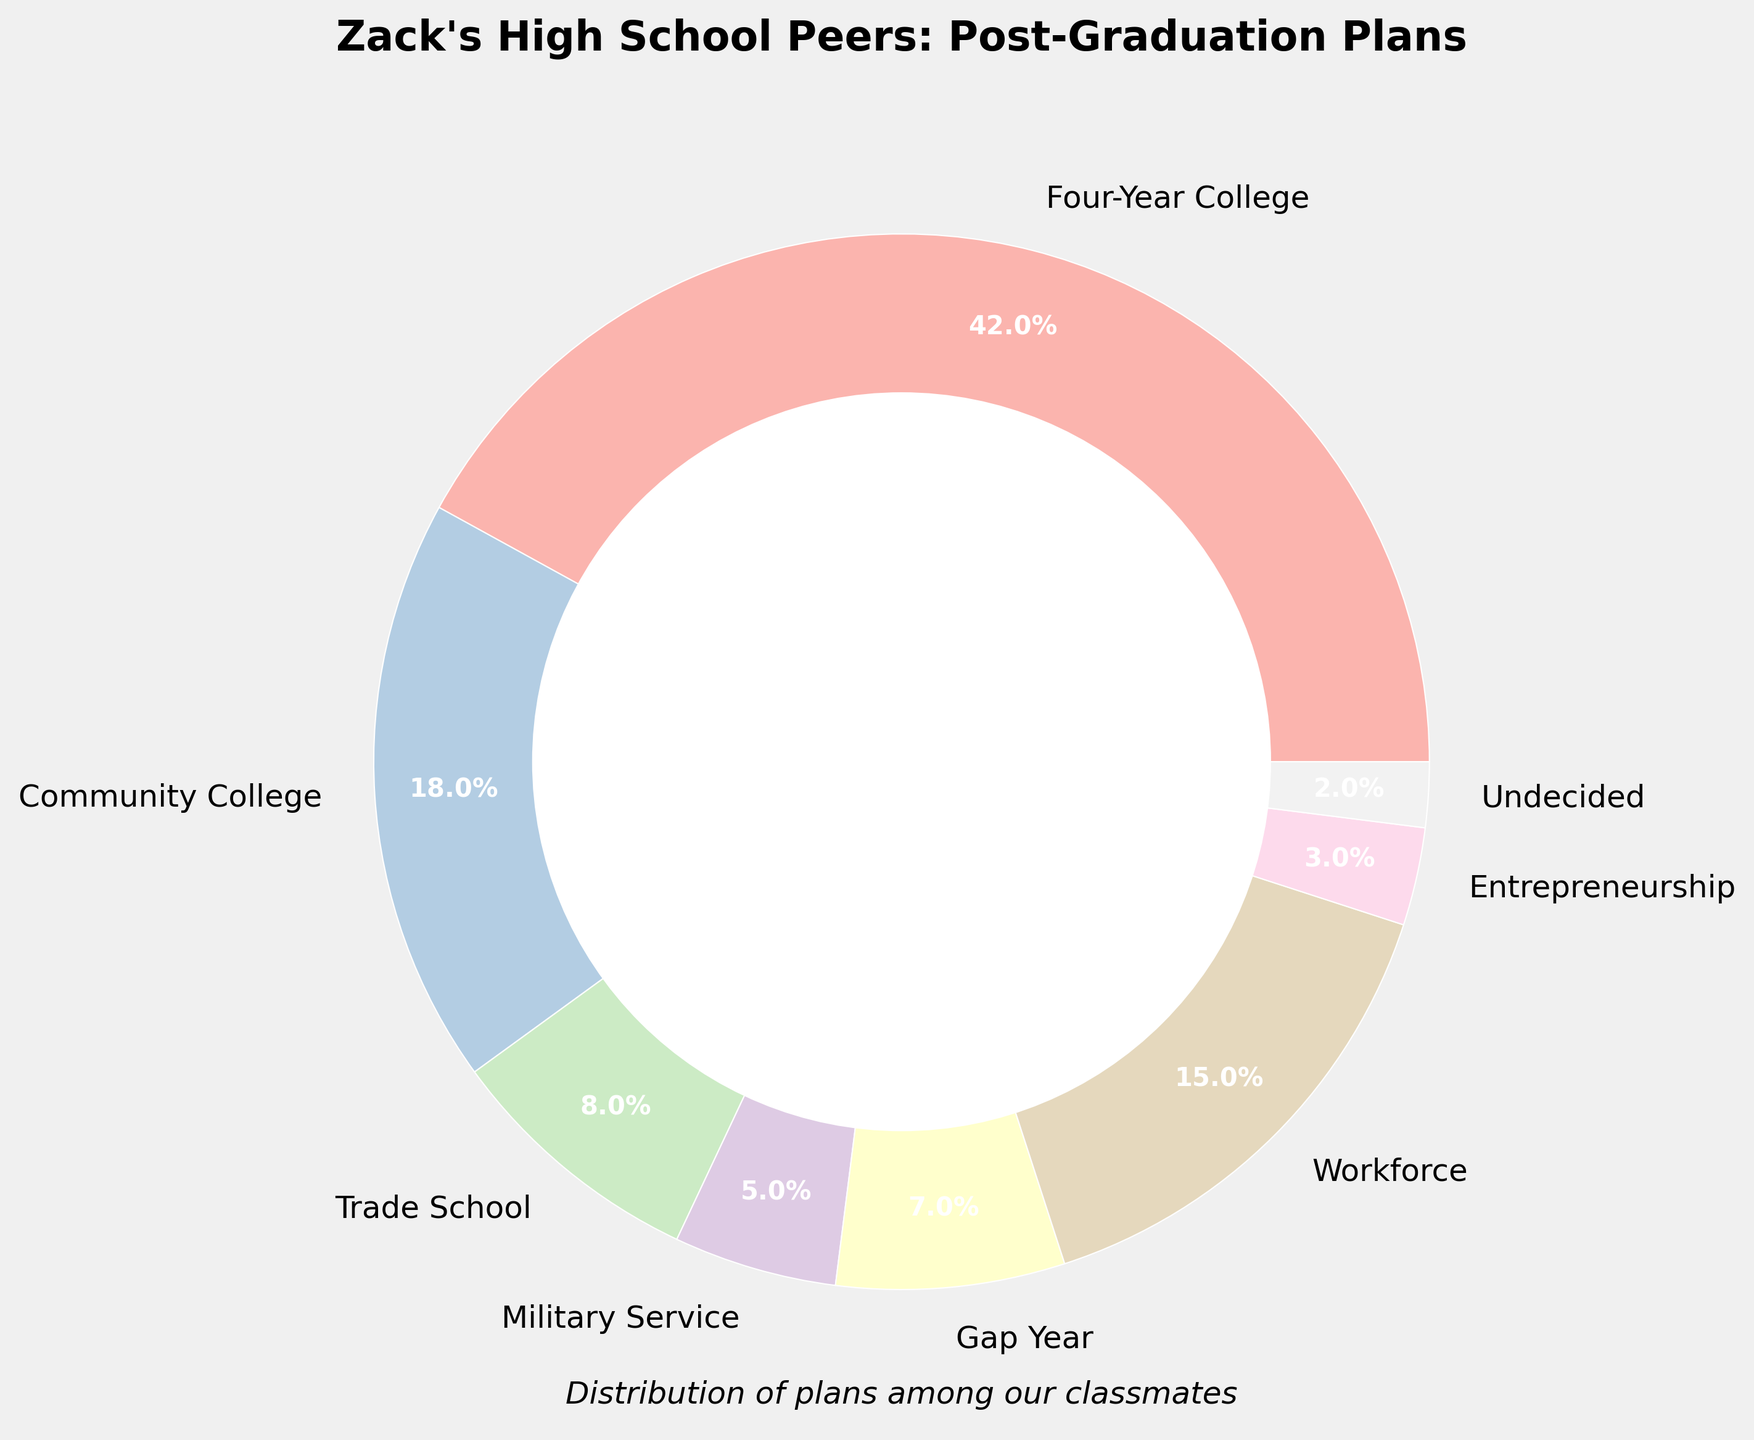What is the most common post-graduation plan among Zack's high school peers? By looking at the pie chart, the largest slice represents the "Four-Year College" category, which has the biggest percentage among all plans.
Answer: Four-Year College Which category has the smallest percentage? Observing the pie chart, the smallest slice belongs to the "Undecided" category.
Answer: Undecided How much larger is the percentage of students planning to attend a Four-Year College than those planning to join the Military Service? The percentage for Four-Year College is 42% and for Military Service is 5%. The difference is 42 - 5 = 37%.
Answer: 37% What is the combined percentage of classmates who plan to attend either a Four-Year College or a Community College? The percentage for Four-Year College is 42% and for Community College is 18%. Adding these gives 42 + 18 = 60%.
Answer: 60% Which post-graduation plan has an 8% share among the peers? By referencing the pie chart, the slice representing "Trade School" accounts for 8%.
Answer: Trade School What is the total percentage of classmates who have decided not to pursue any form of college or trade school? Summing the percentages for Workforce (15%), Military Service (5%), Gap Year (7%), Entrepreneurship (3%), and Undecided (2%) gives 15 + 5 + 7 + 3 + 2 = 32%.
Answer: 32% Compare the percentages of students planning to attend a Community College versus those planning to take a Gap Year. Which is higher and by how much? The Community College percentage is 18% and the Gap Year is 7%. The difference is 18 - 7 = 11%. Community College is higher by 11%.
Answer: Community College, 11% Which two post-graduation plans have a combined percentage of 23%? According to the chart, Military Service (5%) and Workforce (15%) combined add to 20%, however, Trade School (8%) and Workforce (15%) combine to 23%. Hence, Trade School and Workforce are the correct answers.
Answer: Trade School and Workforce What percentage of students plan on entrepreneurial ventures or are undecided? The pie chart shows Entrepreneurship as 3% and Undecided as 2%. Adding these gives 3 + 2 = 5%.
Answer: 5% Which category has a percentage that is more than double that of Military Service? The Military Service percentage is 5%. Community College (18%), Four-Year College (42%), and Workforce (15%) all have percentages more than double that.
Answer: Community College, Four-Year College, Workforce 